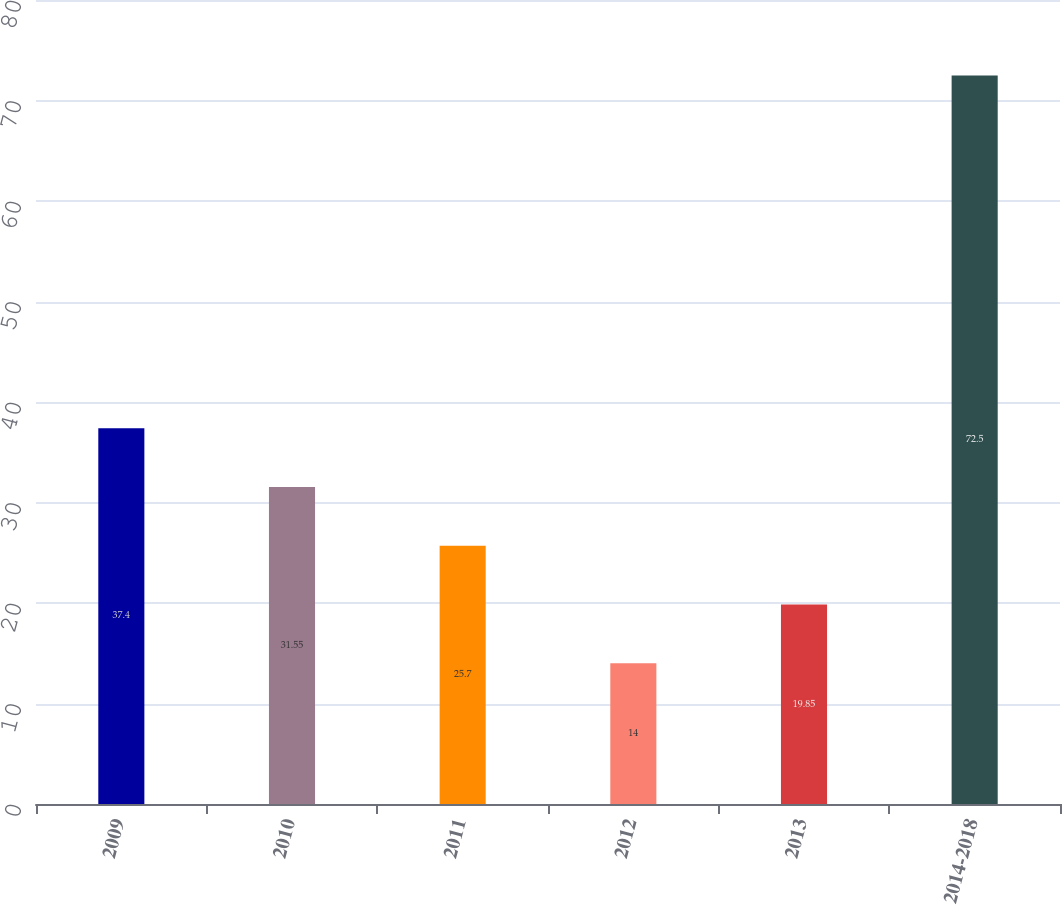Convert chart to OTSL. <chart><loc_0><loc_0><loc_500><loc_500><bar_chart><fcel>2009<fcel>2010<fcel>2011<fcel>2012<fcel>2013<fcel>2014-2018<nl><fcel>37.4<fcel>31.55<fcel>25.7<fcel>14<fcel>19.85<fcel>72.5<nl></chart> 